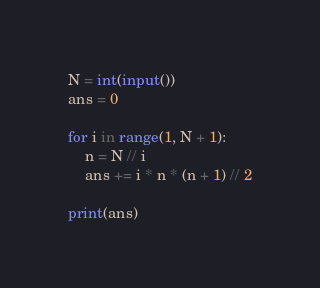Convert code to text. <code><loc_0><loc_0><loc_500><loc_500><_Python_>N = int(input())
ans = 0

for i in range(1, N + 1):
    n = N // i
    ans += i * n * (n + 1) // 2

print(ans)</code> 